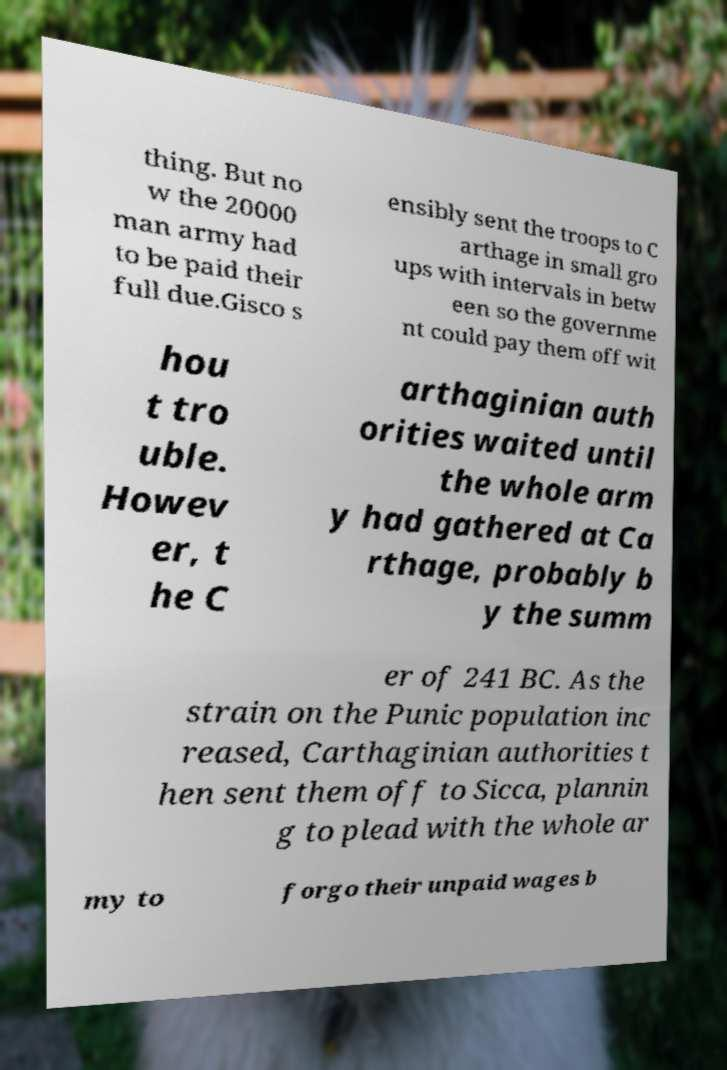Could you assist in decoding the text presented in this image and type it out clearly? thing. But no w the 20000 man army had to be paid their full due.Gisco s ensibly sent the troops to C arthage in small gro ups with intervals in betw een so the governme nt could pay them off wit hou t tro uble. Howev er, t he C arthaginian auth orities waited until the whole arm y had gathered at Ca rthage, probably b y the summ er of 241 BC. As the strain on the Punic population inc reased, Carthaginian authorities t hen sent them off to Sicca, plannin g to plead with the whole ar my to forgo their unpaid wages b 